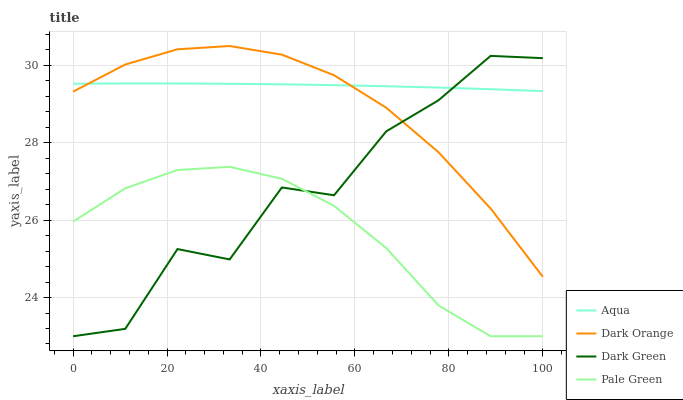Does Pale Green have the minimum area under the curve?
Answer yes or no. Yes. Does Aqua have the maximum area under the curve?
Answer yes or no. Yes. Does Aqua have the minimum area under the curve?
Answer yes or no. No. Does Pale Green have the maximum area under the curve?
Answer yes or no. No. Is Aqua the smoothest?
Answer yes or no. Yes. Is Dark Green the roughest?
Answer yes or no. Yes. Is Pale Green the smoothest?
Answer yes or no. No. Is Pale Green the roughest?
Answer yes or no. No. Does Aqua have the lowest value?
Answer yes or no. No. Does Dark Orange have the highest value?
Answer yes or no. Yes. Does Aqua have the highest value?
Answer yes or no. No. Is Pale Green less than Dark Orange?
Answer yes or no. Yes. Is Aqua greater than Pale Green?
Answer yes or no. Yes. Does Aqua intersect Dark Green?
Answer yes or no. Yes. Is Aqua less than Dark Green?
Answer yes or no. No. Is Aqua greater than Dark Green?
Answer yes or no. No. Does Pale Green intersect Dark Orange?
Answer yes or no. No. 